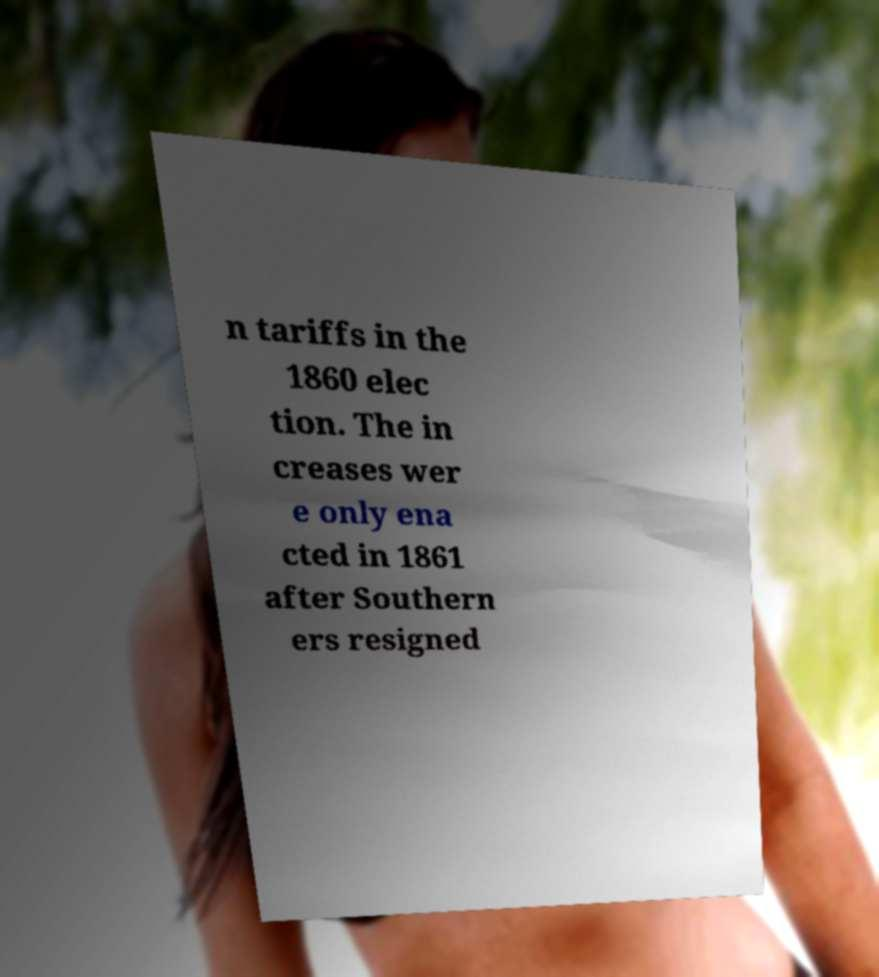I need the written content from this picture converted into text. Can you do that? n tariffs in the 1860 elec tion. The in creases wer e only ena cted in 1861 after Southern ers resigned 